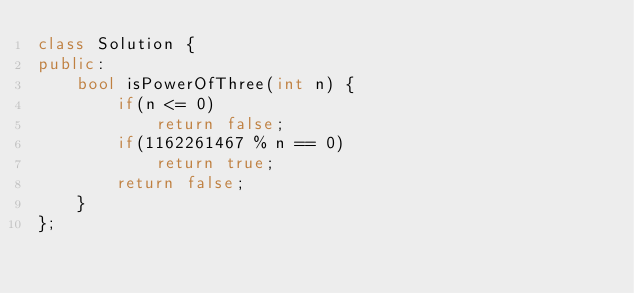<code> <loc_0><loc_0><loc_500><loc_500><_C++_>class Solution {
public:
    bool isPowerOfThree(int n) {
        if(n <= 0)
            return false;
        if(1162261467 % n == 0)
            return true;
        return false;
    }
};</code> 